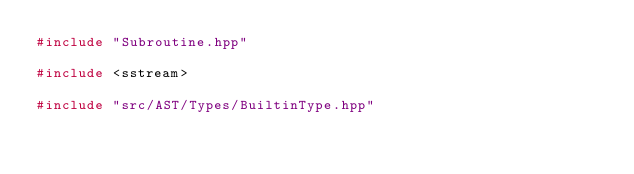Convert code to text. <code><loc_0><loc_0><loc_500><loc_500><_C++_>#include "Subroutine.hpp"

#include <sstream>

#include "src/AST/Types/BuiltinType.hpp"</code> 